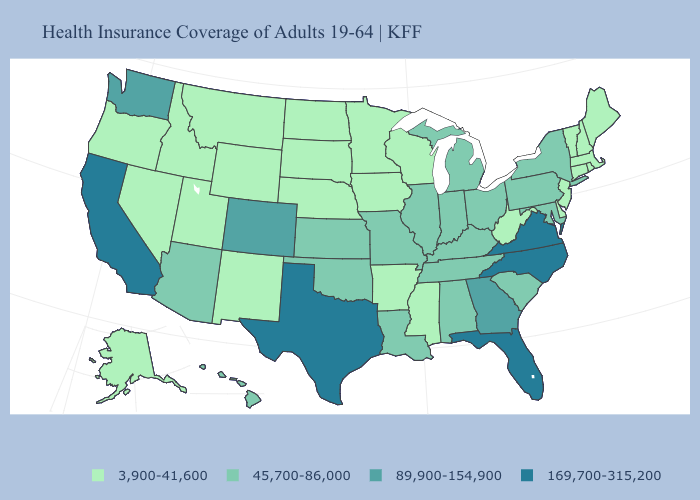How many symbols are there in the legend?
Write a very short answer. 4. Does the first symbol in the legend represent the smallest category?
Write a very short answer. Yes. What is the lowest value in the South?
Give a very brief answer. 3,900-41,600. Does the map have missing data?
Keep it brief. No. Which states have the lowest value in the USA?
Keep it brief. Alaska, Arkansas, Connecticut, Delaware, Idaho, Iowa, Maine, Massachusetts, Minnesota, Mississippi, Montana, Nebraska, Nevada, New Hampshire, New Jersey, New Mexico, North Dakota, Oregon, Rhode Island, South Dakota, Utah, Vermont, West Virginia, Wisconsin, Wyoming. Name the states that have a value in the range 45,700-86,000?
Quick response, please. Alabama, Arizona, Hawaii, Illinois, Indiana, Kansas, Kentucky, Louisiana, Maryland, Michigan, Missouri, New York, Ohio, Oklahoma, Pennsylvania, South Carolina, Tennessee. Which states have the lowest value in the USA?
Quick response, please. Alaska, Arkansas, Connecticut, Delaware, Idaho, Iowa, Maine, Massachusetts, Minnesota, Mississippi, Montana, Nebraska, Nevada, New Hampshire, New Jersey, New Mexico, North Dakota, Oregon, Rhode Island, South Dakota, Utah, Vermont, West Virginia, Wisconsin, Wyoming. Does the first symbol in the legend represent the smallest category?
Concise answer only. Yes. Is the legend a continuous bar?
Keep it brief. No. Name the states that have a value in the range 169,700-315,200?
Concise answer only. California, Florida, North Carolina, Texas, Virginia. What is the value of Missouri?
Quick response, please. 45,700-86,000. How many symbols are there in the legend?
Short answer required. 4. Does California have the highest value in the West?
Write a very short answer. Yes. Which states hav the highest value in the South?
Concise answer only. Florida, North Carolina, Texas, Virginia. 